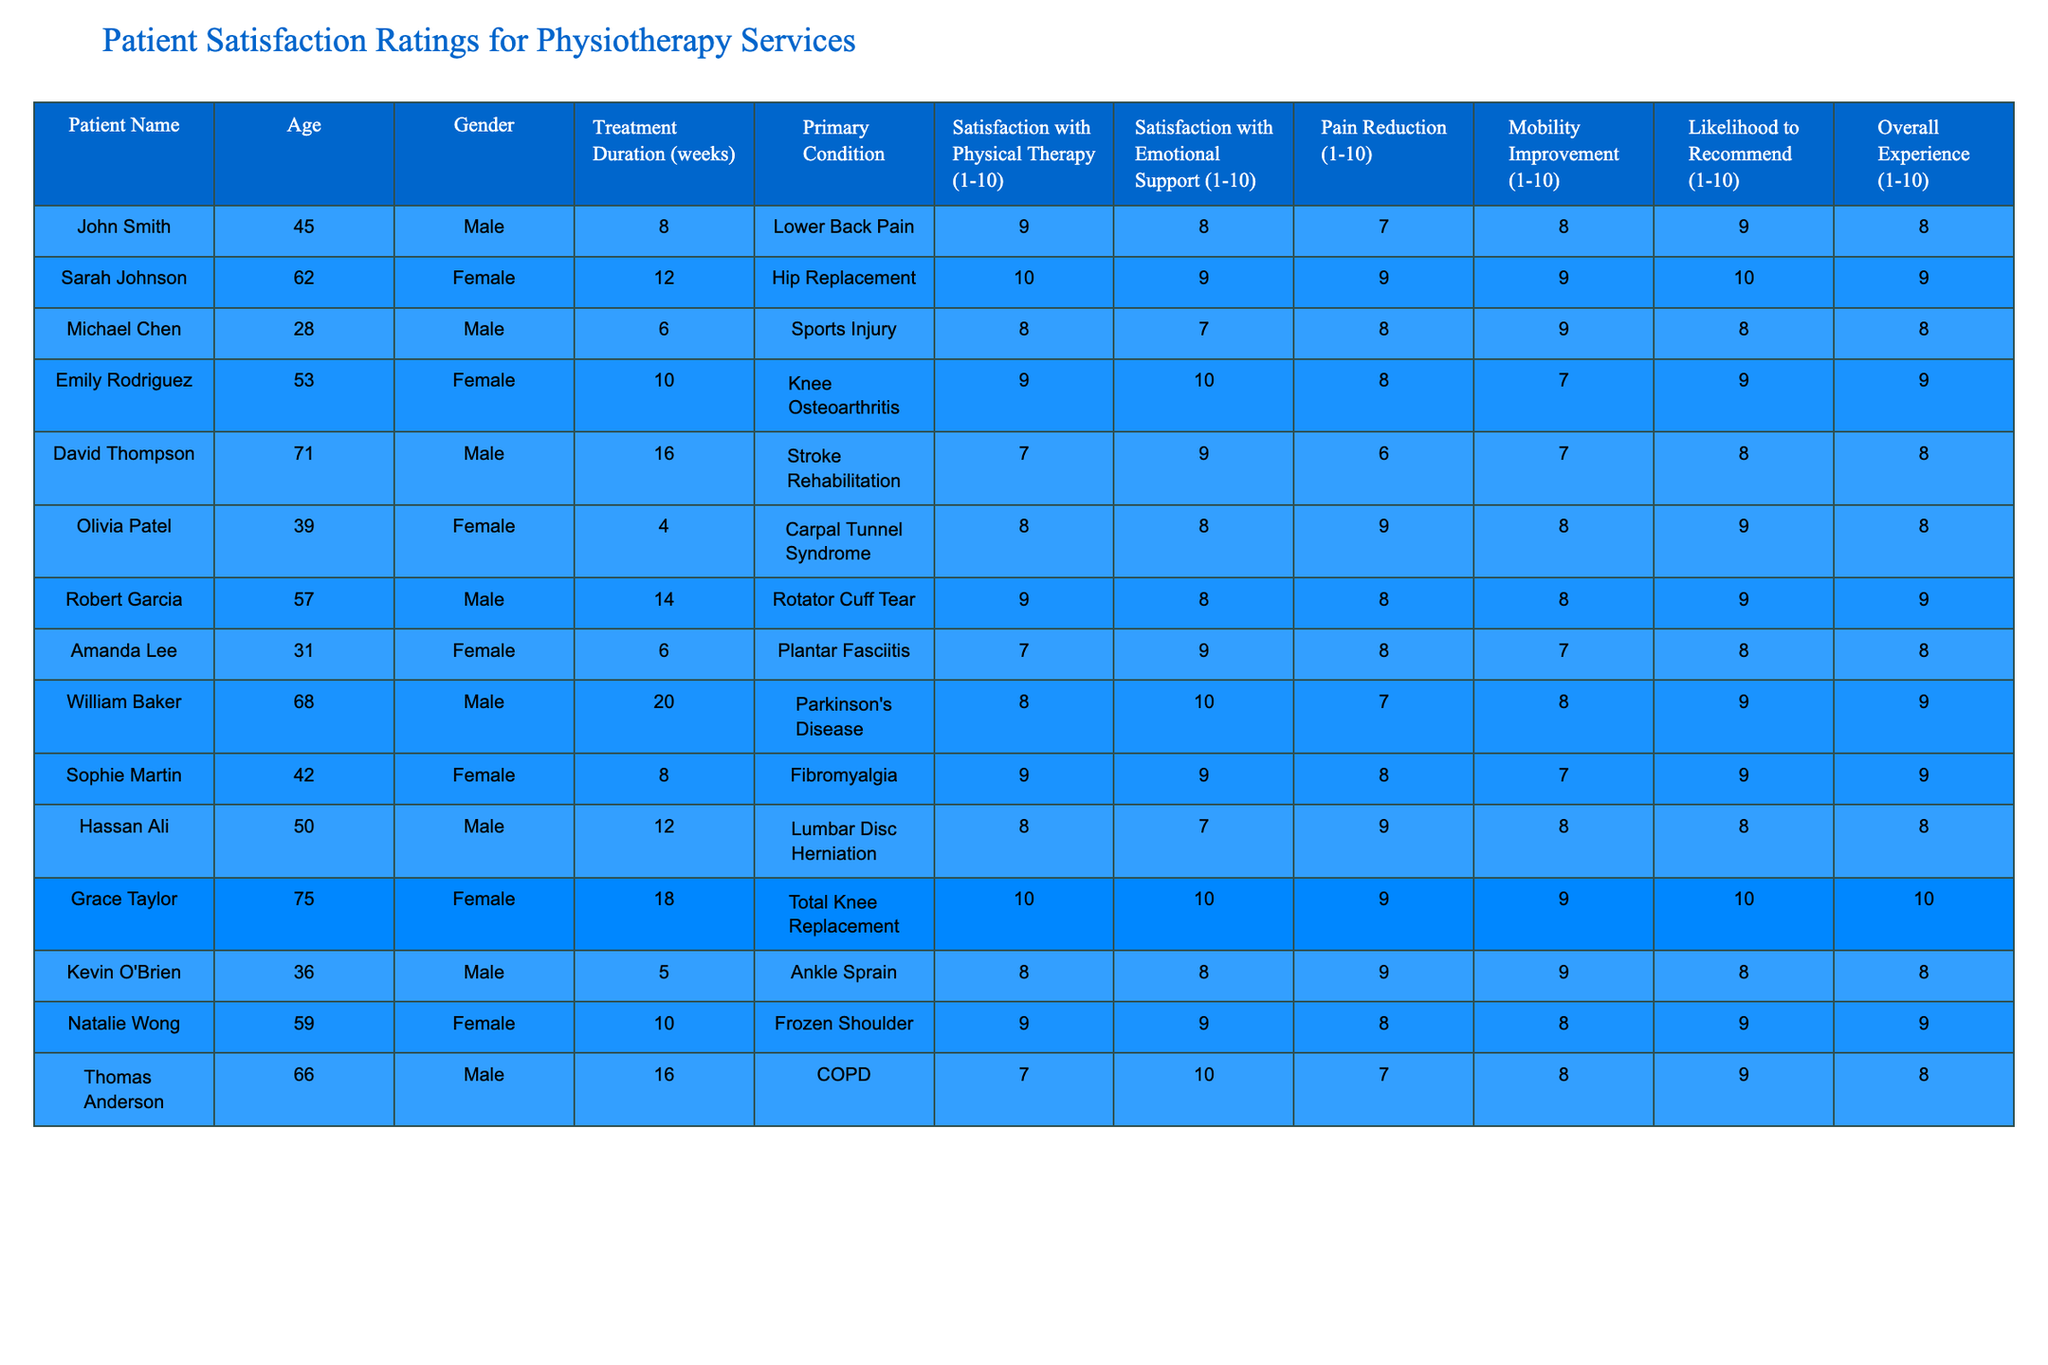What is the highest satisfaction rating for emotional support? By reviewing the "Satisfaction with Emotional Support" column, the highest score is 10, as seen from Grace Taylor and Emily Rodriguez.
Answer: 10 Which patient had the lowest satisfaction with physical therapy? Looking at the "Satisfaction with Physical Therapy" column, David Thompson has the lowest score of 7.
Answer: 7 What percentage of patients rated their overall experience as 10? Two patients (Sarah Johnson and Grace Taylor) rated their overall experience as 10. There are 12 patients total, so (2/12)*100 = 16.67%.
Answer: 16.67% What is the average satisfaction rate for emotional support among female patients? The ratings for female patients are 9, 10, 9, 8, 9, 10, and 9 (total of 7). Adding these gives 64, and the average is 64/7 = 9.14.
Answer: 9.14 Did any patient with a primary condition of 'Stroke Rehabilitation' rate their likelihood to recommend as 9 or higher? David Thompson, who has 'Stroke Rehabilitation', rated their likelihood to recommend as 8, so no patients with that condition rated it 9 or higher.
Answer: No What is the difference in overall experience rating between the youngest and oldest patients? The youngest patient (Michael Chen) rated their overall experience as 8 and the oldest (Grace Taylor) rated it as 10. The difference is 10 - 8 = 2.
Answer: 2 How many patients reported a pain reduction score of 9 or higher? Checking the "Pain Reduction" column, three patients (Olivia Patel, Grace Taylor, and Hassan Ali) reported a score of 9.
Answer: 3 Is there a correlation between treatment duration and satisfaction with emotional support? To assess this, we would need to analyze the treatment duration alongside emotional support ratings. However, visually there’s no clear trend shown in the table.
Answer: Not visually evident Which primary condition had the highest average satisfaction rating for physical therapy? First, we group by primary condition. Lower Back Pain (9), Hip Replacement (10), Sports Injury (8), Knee Osteoarthritis (9), Stroke Rehabilitation (7), Carpal Tunnel Syndrome (8), Rotator Cuff Tear (9), etc. The highest average is from Hip Replacement at 10.
Answer: Hip Replacement What can be inferred about the relationship between mobility improvement and overall experience? Both higher mobility improvement (like 10 by Grace Taylor) and overall experience often have high ratings together, indicating a positive relationship, but this needs statistical analysis for confirmation.
Answer: Generally positive relationship 